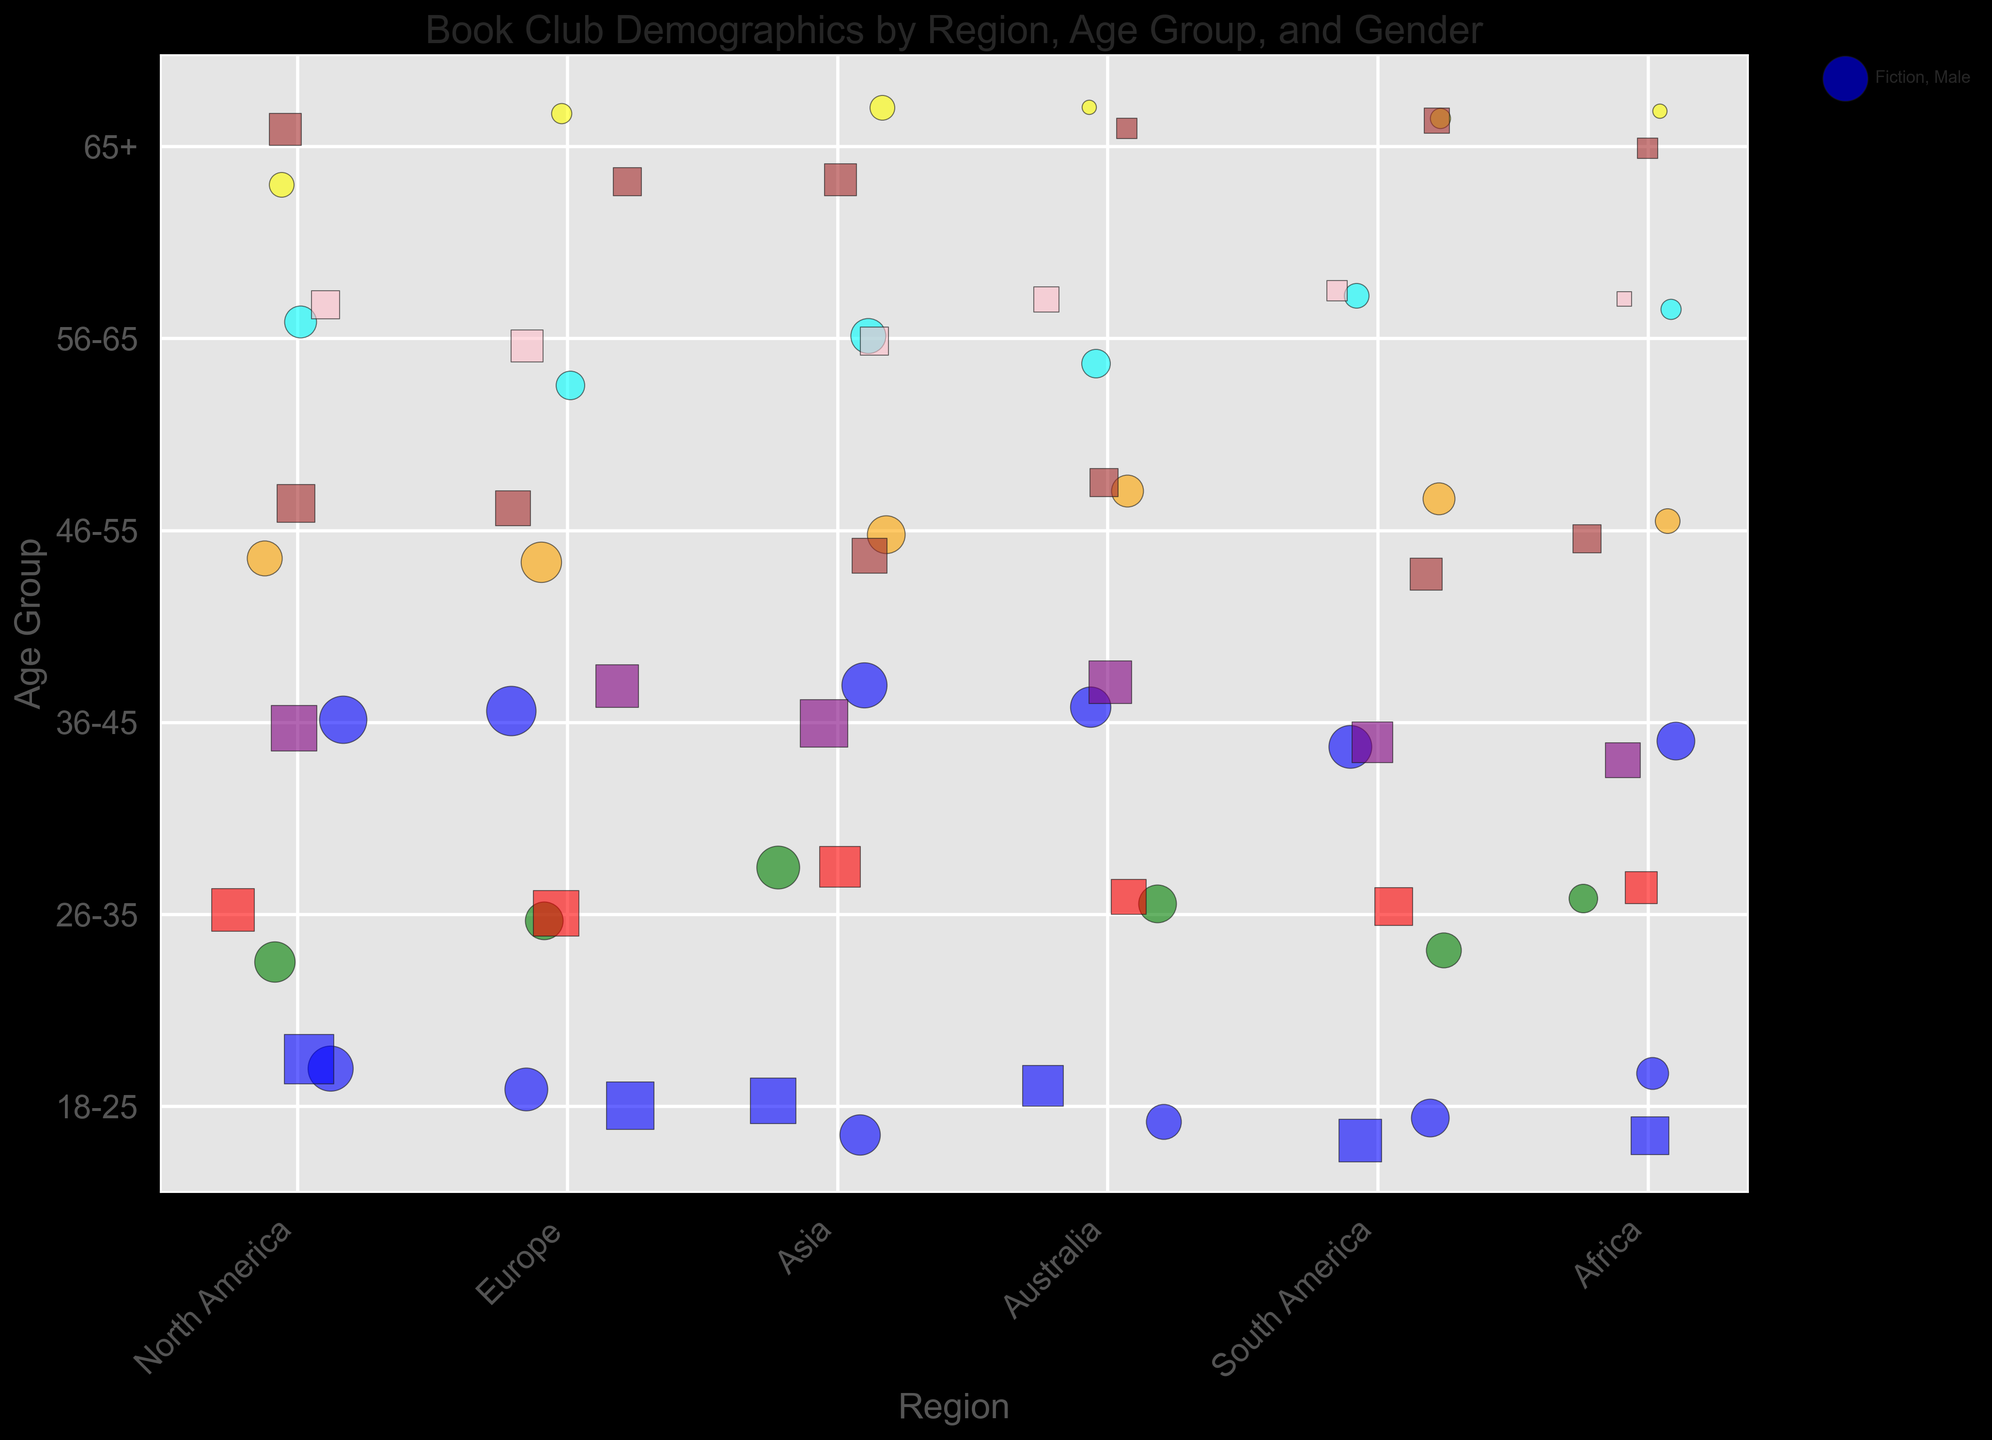What is the most popular genre among 18-25-year-old females in North America? Look at the color and size of the bubbles for the 18-25 age group and female gender in North America. Identify the genre associated with the largest bubble. It corresponds to the blue color (Fiction).
Answer: Fiction Which region has the largest member count for the favorite genre "Science Fiction" among 26-35-year-old males? Examine all regions for the plotted bubbles representing 26-35-year-old males and the color corresponding to Science Fiction (green). Compare bubble sizes for each region. The largest bubble is for North America.
Answer: North America What is the combined total member count for Fiction among 36-45-year-old males across all regions? Locate all bubbles corresponding to 36-45-year-old males with Fiction as the favorite genre (blue bubbles in the respective age group) in each region. Sum the member counts: 55 (North America) + 60 (Europe) + 50 (Asia) + 40 (Australia) + 45 (South America) + 35 (Africa) = 285.
Answer: 285 Are there more female members who prefer Mystery or Romance in the 46-55 age group in all regions combined? Identify and sum the member counts for Mystery and Romance among 46-55-year-old females across all regions. Compare the two sums: Mystery: 35 (North America) + 30 (Europe) + 30 (Asia) + 20 (Australia) + 25 (South America) + 20 (Africa) = 160. Romance: 45 (North America) + 50 (Europe) + 40 (Asia) + 30 (Australia) + 35 (South America) + 25 (Africa) = 225.
Answer: Romance What is the favorite genre that appears frequently among females aged 65+? Examine the 65+ age group for females across all regions, noting the colors associated with each genre. Mystery (brown) appears more frequently and is consistently present.
Answer: Mystery 